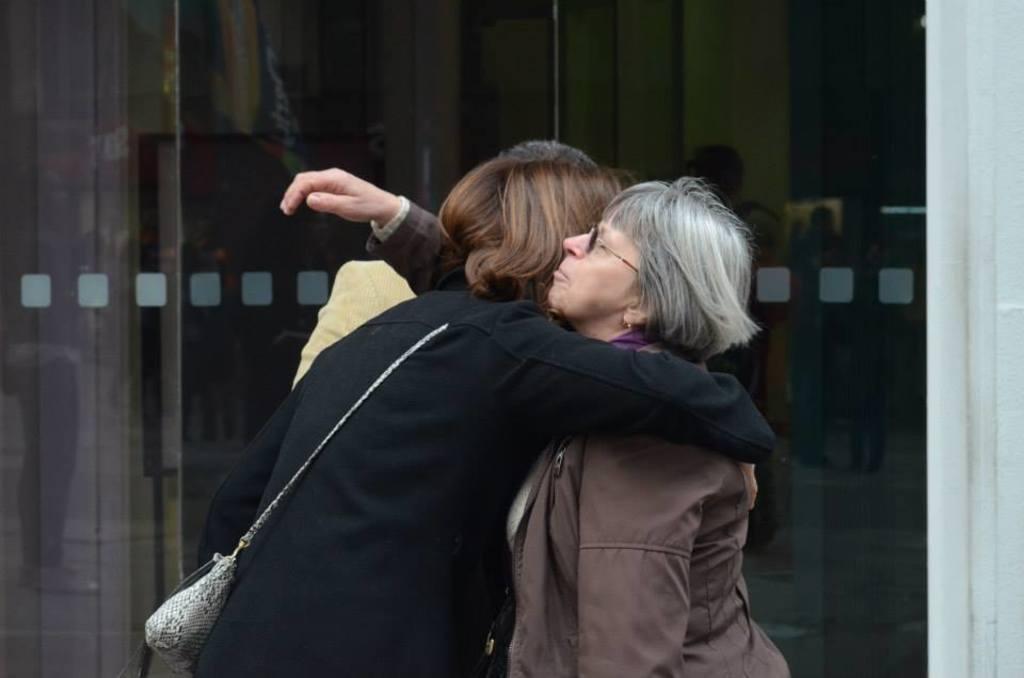Please provide a concise description of this image. In this image we can see two persons wearing jackets are standing and hugging each other. In the background, we can see the glass doors through which we can see the reflection of a few more people and we can see the wall here. 